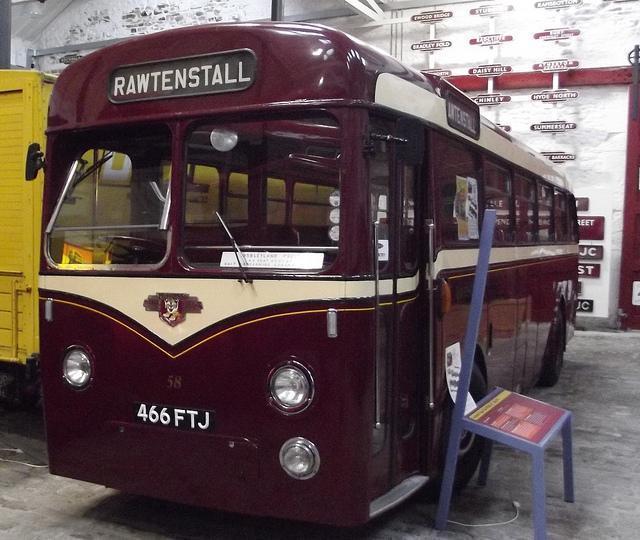What does the information on the blue legged placard describe?
Choose the right answer from the provided options to respond to the question.
Options: Bus, motorcycle, menu, protest. Bus. 